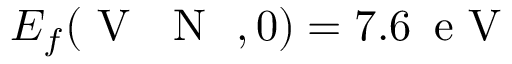<formula> <loc_0><loc_0><loc_500><loc_500>E _ { f } ( V \text  subscript { N } , 0 ) = 7 . 6 \, e V</formula> 